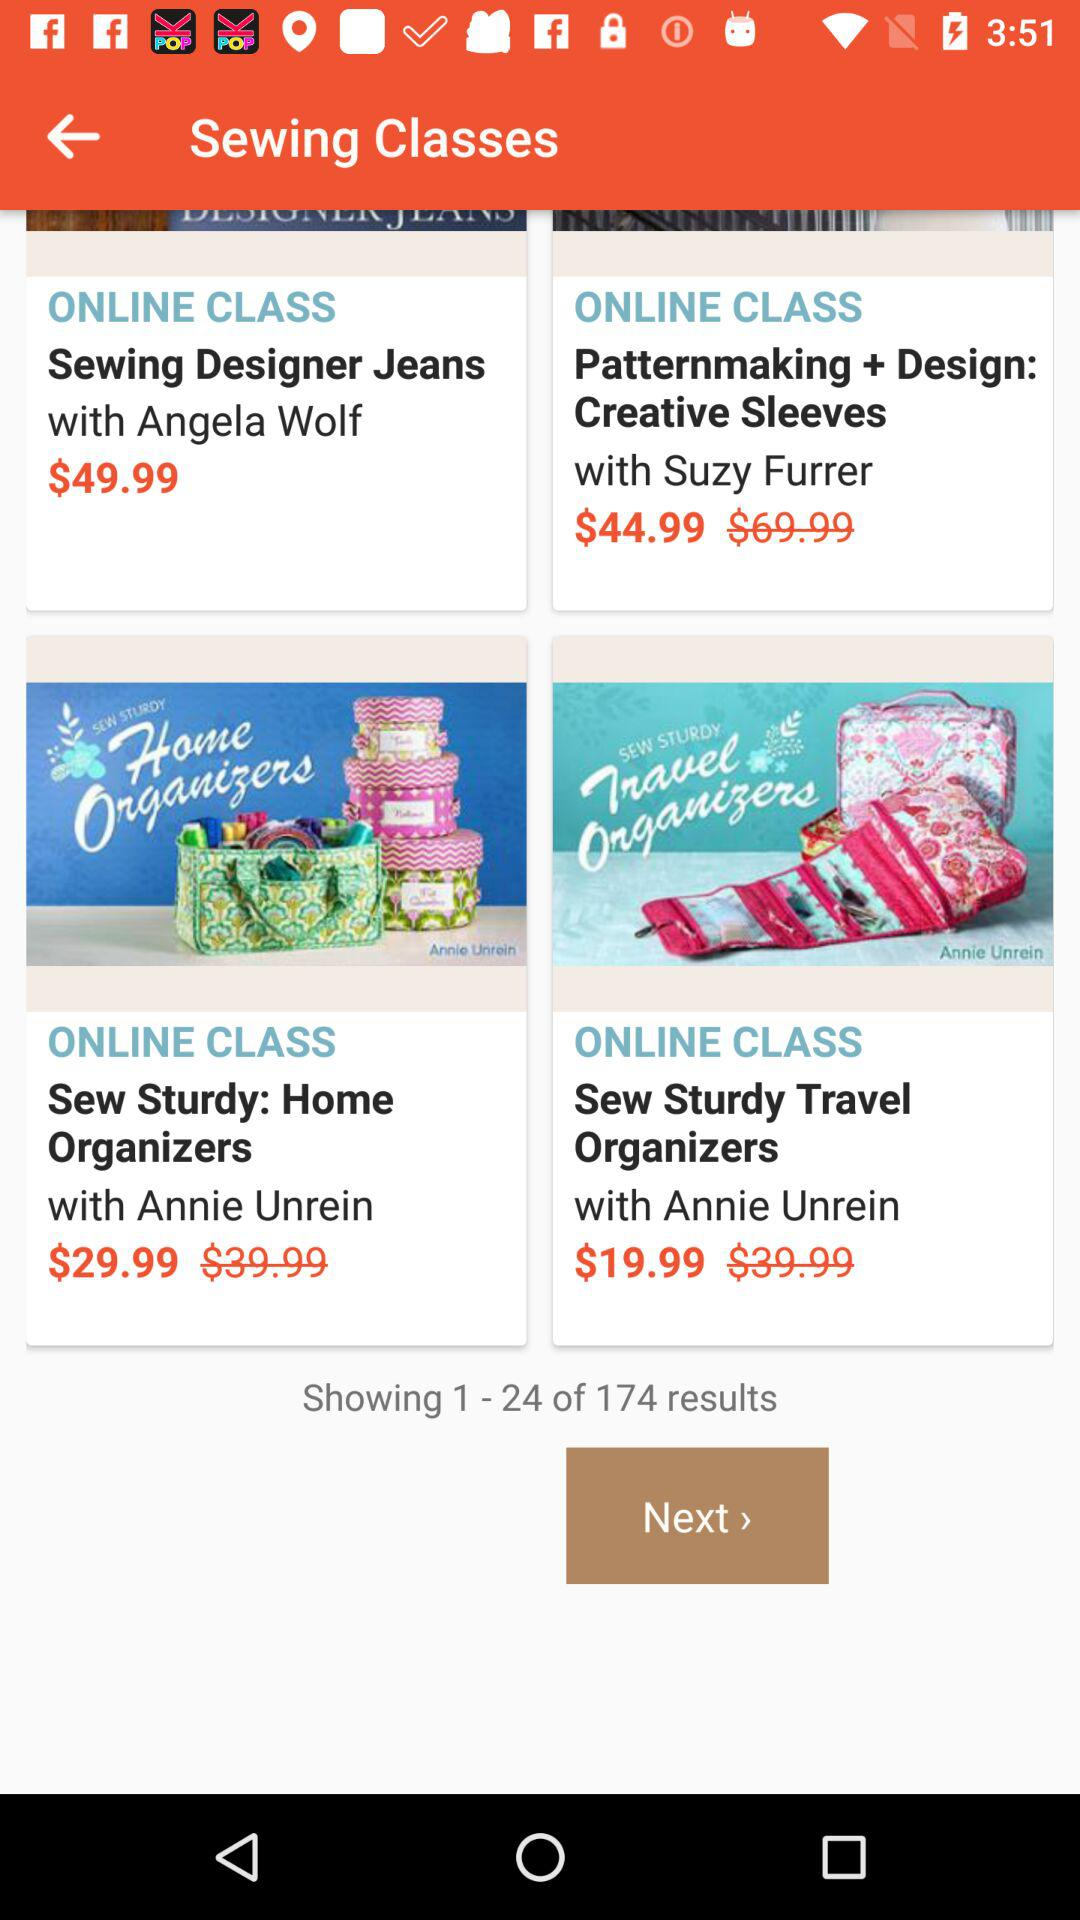What is the application name? The application name is "Sewing Classes". 